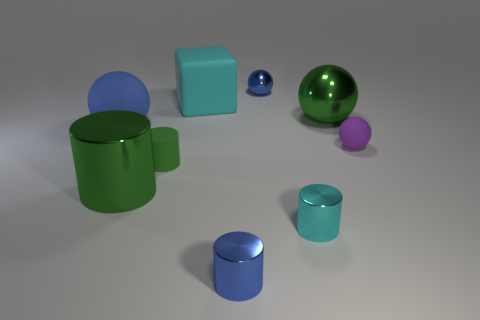There is another ball that is the same color as the small metallic ball; what size is it?
Keep it short and to the point. Large. There is a big matte thing that is the same shape as the tiny purple thing; what is its color?
Your answer should be very brief. Blue. The small purple matte thing has what shape?
Offer a very short reply. Sphere. How many objects are either small green things or small purple matte spheres?
Ensure brevity in your answer.  2. There is a large metal object behind the green rubber object; does it have the same color as the tiny rubber object that is to the left of the large green ball?
Offer a terse response. Yes. What number of other objects are there of the same shape as the cyan metal thing?
Offer a terse response. 3. Are there any cyan metallic blocks?
Make the answer very short. No. How many things are small gray metallic balls or large spheres behind the tiny blue cylinder?
Keep it short and to the point. 2. Does the matte ball that is right of the green rubber cylinder have the same size as the large metal cylinder?
Your answer should be compact. No. How many other objects are the same size as the cyan metal cylinder?
Make the answer very short. 4. 